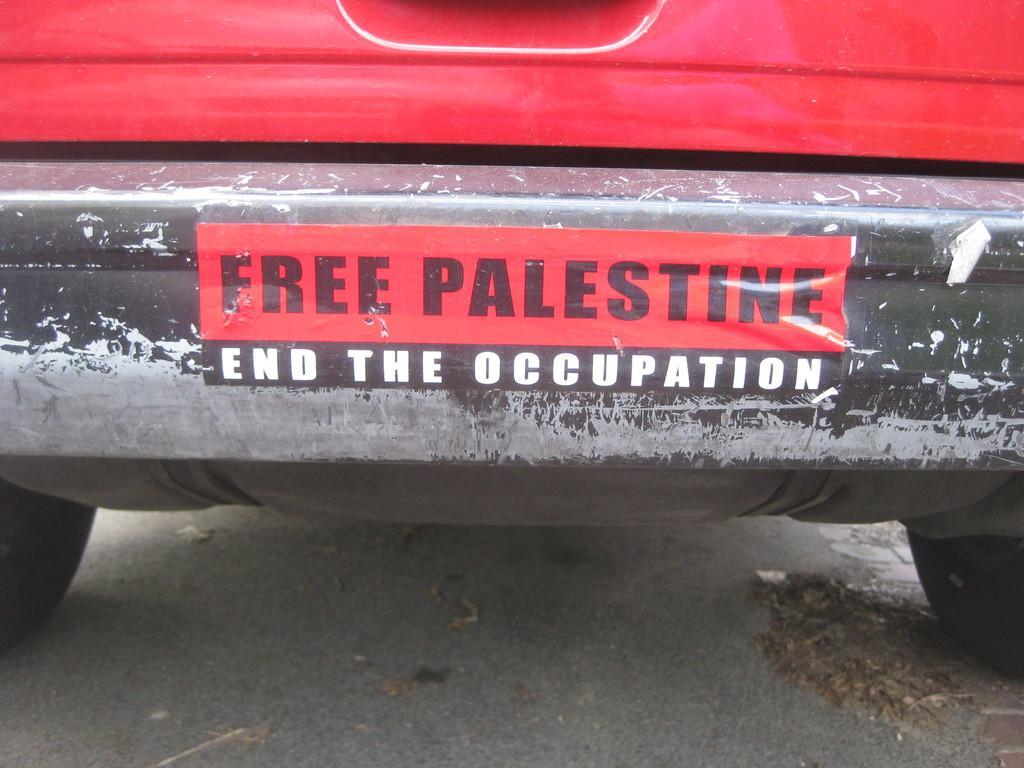Describe this image in one or two sentences. In this picture we can see a vehicle and we can find a sticker on the vehicle. 